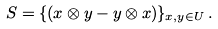Convert formula to latex. <formula><loc_0><loc_0><loc_500><loc_500>S = \{ ( x \otimes y - y \otimes x ) \} _ { x , y \in U } \, .</formula> 